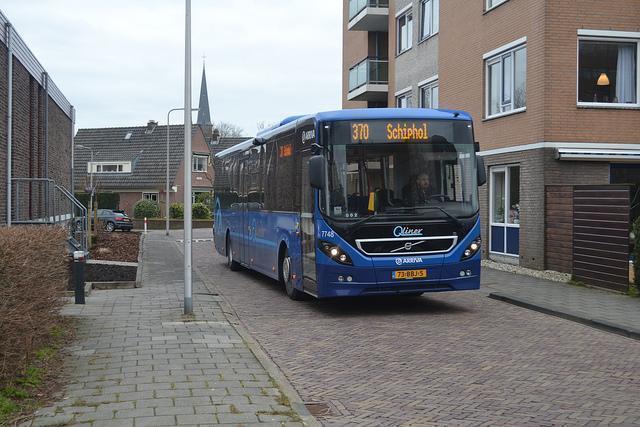What kind of problem is likely to be experienced by the apartment residents?
Choose the correct response and explain in the format: 'Answer: answer
Rationale: rationale.'
Options: Noise, pollution, graffiti, burglary. Answer: noise.
Rationale: There is a road extremely close to the building, so traffic may be keeping the residents up at night. What do people do inside the building with the spire on it?
Indicate the correct response by choosing from the four available options to answer the question.
Options: Play chess, worship, party, eat out. Worship. 